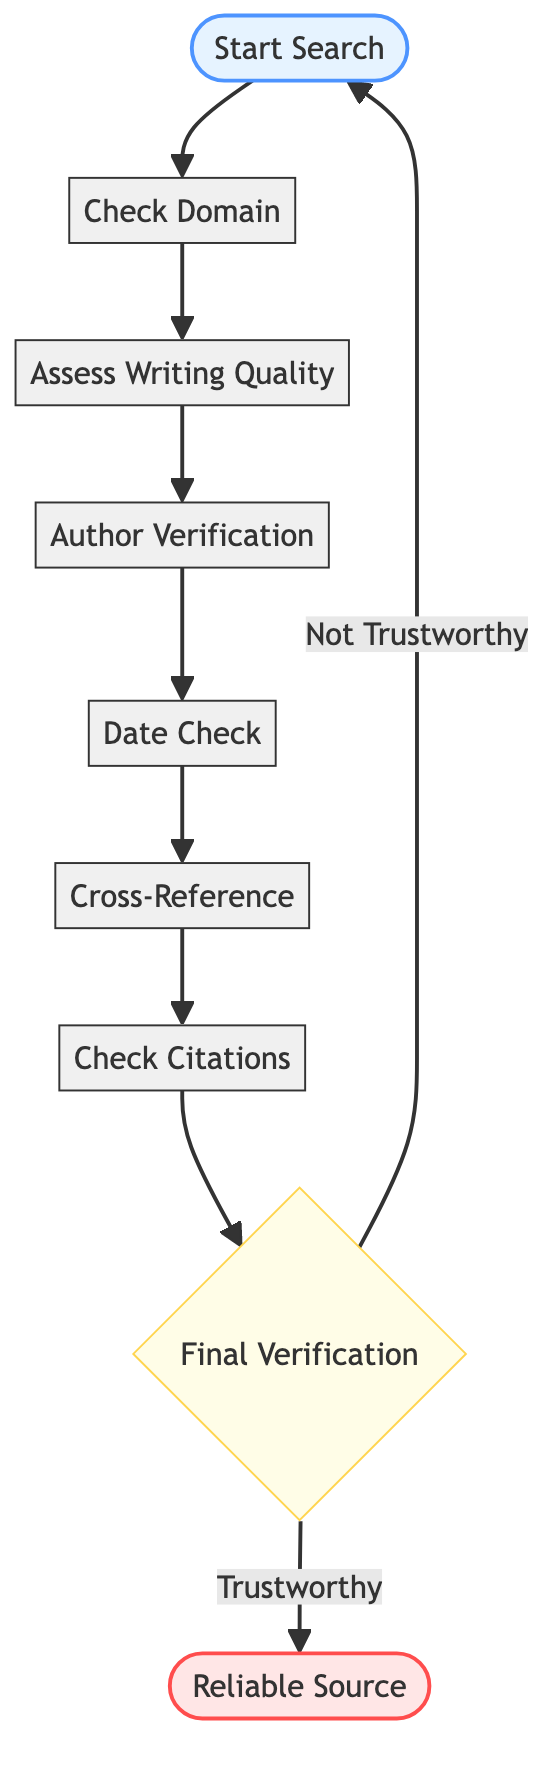What is the first step in the flow chart? The first step shown in the flow chart is "Start Search", indicated at the beginning of the diagram.
Answer: Start Search How many steps are in the flow chart? The flow chart contains a total of eight steps from "Start Search" to "Check Citations" before reaching the decision point "Final Verification".
Answer: Eight What should you evaluate in the "Check Domain" step? In the "Check Domain" step, you should evaluate the domain of the resource, which is crucial for determining its trustworthiness.
Answer: The domain What comes after "Date Check"? The step that follows "Date Check" is "Cross-Reference", indicating that after checking the publication date, the next action is to verify the information with other reliable sources.
Answer: Cross-Reference What happens if the resource is deemed "Not Trustworthy"? If the resource is classified as "Not Trustworthy", the flow chart indicates that the process loops back to "Start Search" to begin the evaluation again.
Answer: Start Search What type of websites does the chart suggest to avoid in the Check Domain step? The chart suggests avoiding websites with the ".com" domain unless they are reputable and well-known, such as "bbc.com" or "nytimes.com".
Answer: ".com" Which step evaluates the author's credentials? The step that evaluates the author's credentials is "Author Verification", where you determine the credibility of the author based on their background and published works.
Answer: Author Verification What is the final decision point in the flow chart? The final decision point in the flow chart is "Final Verification", which assesses the overall trustworthiness of the resource before confirming it as reliable or not.
Answer: Final Verification What detail is suggested to examine in "Check Citations"? In the "Check Citations" step, it is suggested to examine the references and citations provided to determine if they reference other credible sources, which adds to the reliability of the article.
Answer: References and citations 